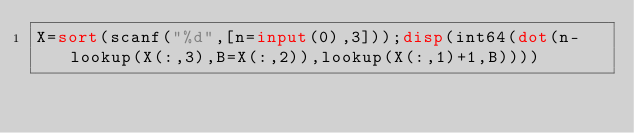Convert code to text. <code><loc_0><loc_0><loc_500><loc_500><_Octave_>X=sort(scanf("%d",[n=input(0),3]));disp(int64(dot(n-lookup(X(:,3),B=X(:,2)),lookup(X(:,1)+1,B))))</code> 